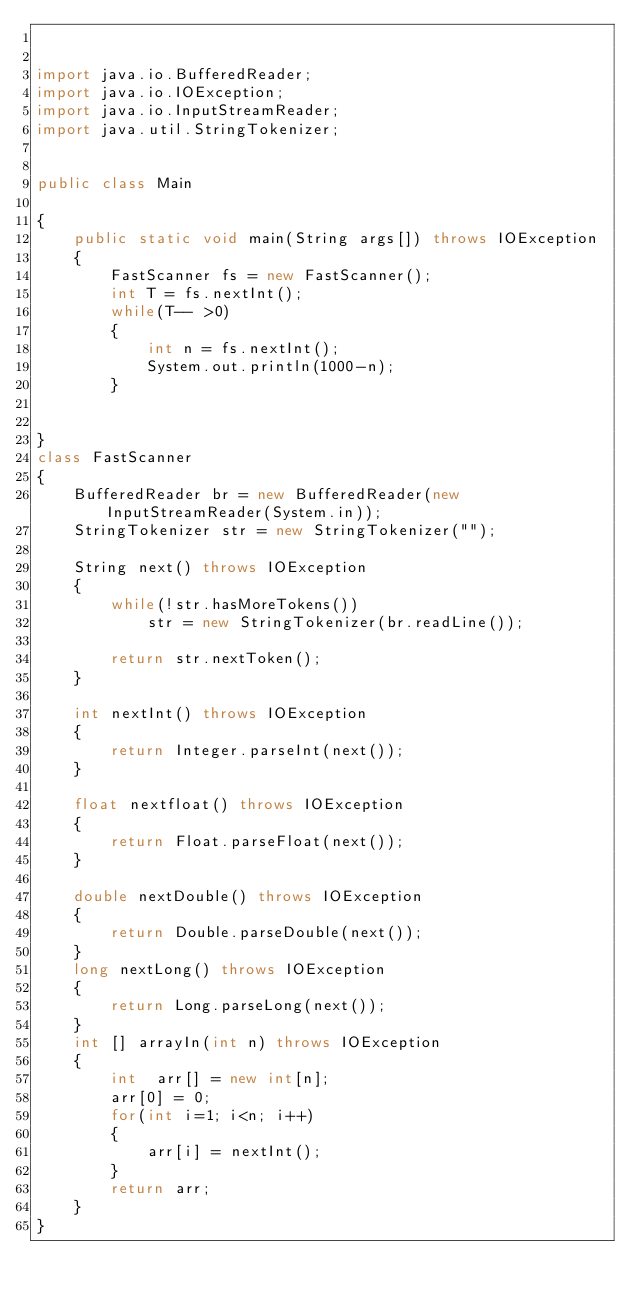<code> <loc_0><loc_0><loc_500><loc_500><_Java_>

import java.io.BufferedReader;
import java.io.IOException;
import java.io.InputStreamReader;
import java.util.StringTokenizer;


public class Main

{	
	public static void main(String args[]) throws IOException
	{
		FastScanner fs = new FastScanner();
		int T = fs.nextInt();
		while(T-- >0)
		{
			int n = fs.nextInt();
			System.out.println(1000-n);
		}


}
class FastScanner
{
	BufferedReader br = new BufferedReader(new InputStreamReader(System.in));
	StringTokenizer str = new StringTokenizer("");
	
	String next() throws IOException
	{
		while(!str.hasMoreTokens())
			str = new StringTokenizer(br.readLine());
		
		return str.nextToken();
	}
	
	int nextInt() throws IOException
	{
		return Integer.parseInt(next());
	}
	
	float nextfloat() throws IOException
	{
		return Float.parseFloat(next());
	}
	
	double nextDouble() throws IOException
	{
		return Double.parseDouble(next());
	}
	long nextLong() throws IOException
	{
		return Long.parseLong(next());
	}
	int [] arrayIn(int n) throws IOException
	{
		int  arr[] = new int[n];
		arr[0] = 0;
		for(int i=1; i<n; i++)
		{
			arr[i] = nextInt();
		}
		return arr;
	}
}



	</code> 